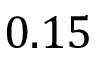Convert formula to latex. <formula><loc_0><loc_0><loc_500><loc_500>0 . 1 5</formula> 